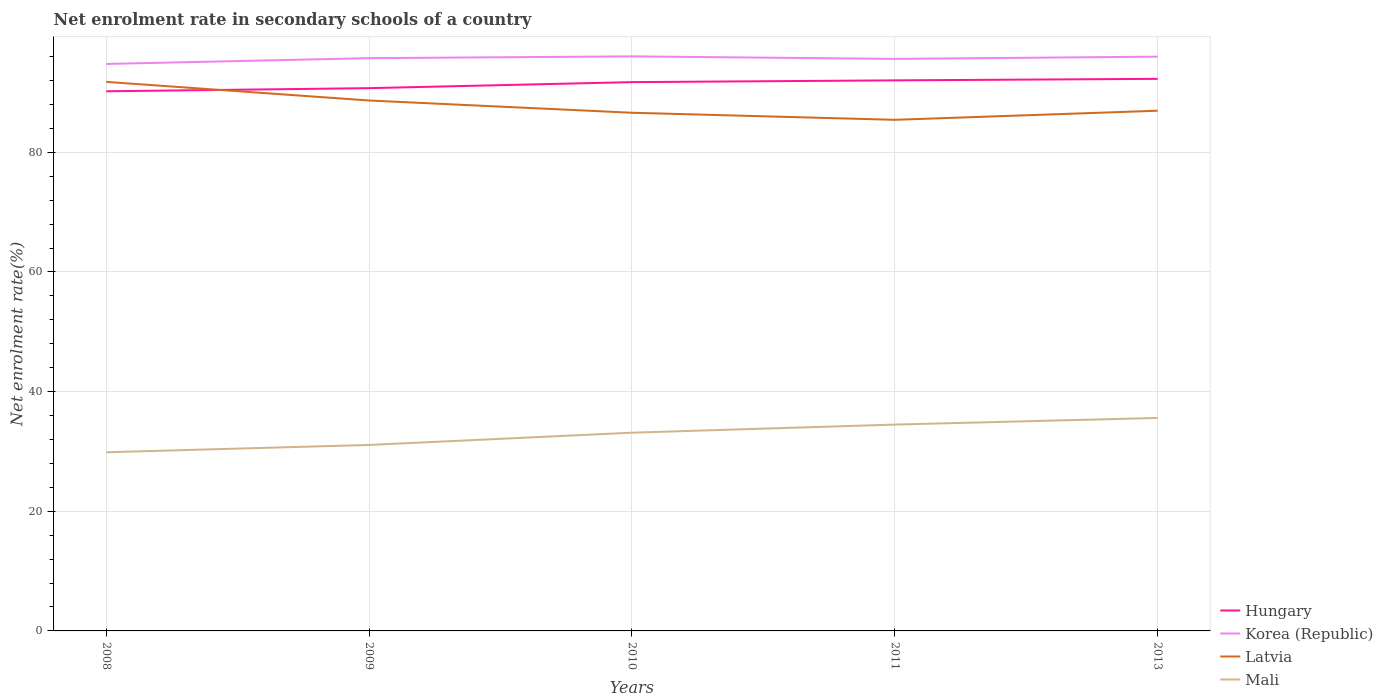How many different coloured lines are there?
Provide a succinct answer. 4. Does the line corresponding to Latvia intersect with the line corresponding to Korea (Republic)?
Your answer should be compact. No. Is the number of lines equal to the number of legend labels?
Provide a short and direct response. Yes. Across all years, what is the maximum net enrolment rate in secondary schools in Hungary?
Offer a terse response. 90.2. What is the total net enrolment rate in secondary schools in Korea (Republic) in the graph?
Provide a short and direct response. 0.42. What is the difference between the highest and the second highest net enrolment rate in secondary schools in Mali?
Make the answer very short. 5.74. Are the values on the major ticks of Y-axis written in scientific E-notation?
Ensure brevity in your answer.  No. Where does the legend appear in the graph?
Offer a very short reply. Bottom right. How are the legend labels stacked?
Offer a very short reply. Vertical. What is the title of the graph?
Keep it short and to the point. Net enrolment rate in secondary schools of a country. What is the label or title of the Y-axis?
Make the answer very short. Net enrolment rate(%). What is the Net enrolment rate(%) in Hungary in 2008?
Your response must be concise. 90.2. What is the Net enrolment rate(%) in Korea (Republic) in 2008?
Your answer should be very brief. 94.76. What is the Net enrolment rate(%) of Latvia in 2008?
Your answer should be compact. 91.77. What is the Net enrolment rate(%) of Mali in 2008?
Offer a terse response. 29.86. What is the Net enrolment rate(%) in Hungary in 2009?
Your response must be concise. 90.72. What is the Net enrolment rate(%) in Korea (Republic) in 2009?
Your answer should be compact. 95.73. What is the Net enrolment rate(%) in Latvia in 2009?
Give a very brief answer. 88.65. What is the Net enrolment rate(%) in Mali in 2009?
Provide a succinct answer. 31.09. What is the Net enrolment rate(%) in Hungary in 2010?
Provide a succinct answer. 91.72. What is the Net enrolment rate(%) of Korea (Republic) in 2010?
Ensure brevity in your answer.  96.03. What is the Net enrolment rate(%) of Latvia in 2010?
Provide a short and direct response. 86.61. What is the Net enrolment rate(%) in Mali in 2010?
Ensure brevity in your answer.  33.13. What is the Net enrolment rate(%) of Hungary in 2011?
Your answer should be very brief. 92.02. What is the Net enrolment rate(%) in Korea (Republic) in 2011?
Offer a very short reply. 95.61. What is the Net enrolment rate(%) of Latvia in 2011?
Keep it short and to the point. 85.43. What is the Net enrolment rate(%) in Mali in 2011?
Provide a short and direct response. 34.49. What is the Net enrolment rate(%) in Hungary in 2013?
Give a very brief answer. 92.27. What is the Net enrolment rate(%) of Korea (Republic) in 2013?
Keep it short and to the point. 95.98. What is the Net enrolment rate(%) of Latvia in 2013?
Keep it short and to the point. 86.94. What is the Net enrolment rate(%) in Mali in 2013?
Ensure brevity in your answer.  35.6. Across all years, what is the maximum Net enrolment rate(%) of Hungary?
Ensure brevity in your answer.  92.27. Across all years, what is the maximum Net enrolment rate(%) of Korea (Republic)?
Your response must be concise. 96.03. Across all years, what is the maximum Net enrolment rate(%) of Latvia?
Your response must be concise. 91.77. Across all years, what is the maximum Net enrolment rate(%) in Mali?
Your response must be concise. 35.6. Across all years, what is the minimum Net enrolment rate(%) in Hungary?
Keep it short and to the point. 90.2. Across all years, what is the minimum Net enrolment rate(%) of Korea (Republic)?
Your answer should be very brief. 94.76. Across all years, what is the minimum Net enrolment rate(%) of Latvia?
Provide a succinct answer. 85.43. Across all years, what is the minimum Net enrolment rate(%) of Mali?
Offer a terse response. 29.86. What is the total Net enrolment rate(%) of Hungary in the graph?
Provide a short and direct response. 456.93. What is the total Net enrolment rate(%) of Korea (Republic) in the graph?
Provide a succinct answer. 478.12. What is the total Net enrolment rate(%) in Latvia in the graph?
Provide a succinct answer. 439.4. What is the total Net enrolment rate(%) in Mali in the graph?
Offer a terse response. 164.16. What is the difference between the Net enrolment rate(%) of Hungary in 2008 and that in 2009?
Keep it short and to the point. -0.52. What is the difference between the Net enrolment rate(%) in Korea (Republic) in 2008 and that in 2009?
Make the answer very short. -0.97. What is the difference between the Net enrolment rate(%) of Latvia in 2008 and that in 2009?
Provide a succinct answer. 3.11. What is the difference between the Net enrolment rate(%) of Mali in 2008 and that in 2009?
Your answer should be compact. -1.23. What is the difference between the Net enrolment rate(%) in Hungary in 2008 and that in 2010?
Ensure brevity in your answer.  -1.53. What is the difference between the Net enrolment rate(%) in Korea (Republic) in 2008 and that in 2010?
Offer a very short reply. -1.27. What is the difference between the Net enrolment rate(%) of Latvia in 2008 and that in 2010?
Your response must be concise. 5.16. What is the difference between the Net enrolment rate(%) of Mali in 2008 and that in 2010?
Your response must be concise. -3.27. What is the difference between the Net enrolment rate(%) of Hungary in 2008 and that in 2011?
Offer a very short reply. -1.82. What is the difference between the Net enrolment rate(%) of Korea (Republic) in 2008 and that in 2011?
Give a very brief answer. -0.85. What is the difference between the Net enrolment rate(%) in Latvia in 2008 and that in 2011?
Give a very brief answer. 6.34. What is the difference between the Net enrolment rate(%) of Mali in 2008 and that in 2011?
Ensure brevity in your answer.  -4.63. What is the difference between the Net enrolment rate(%) in Hungary in 2008 and that in 2013?
Keep it short and to the point. -2.08. What is the difference between the Net enrolment rate(%) in Korea (Republic) in 2008 and that in 2013?
Keep it short and to the point. -1.22. What is the difference between the Net enrolment rate(%) in Latvia in 2008 and that in 2013?
Your response must be concise. 4.82. What is the difference between the Net enrolment rate(%) in Mali in 2008 and that in 2013?
Your answer should be very brief. -5.74. What is the difference between the Net enrolment rate(%) in Hungary in 2009 and that in 2010?
Your answer should be compact. -1.01. What is the difference between the Net enrolment rate(%) in Korea (Republic) in 2009 and that in 2010?
Provide a succinct answer. -0.3. What is the difference between the Net enrolment rate(%) in Latvia in 2009 and that in 2010?
Give a very brief answer. 2.05. What is the difference between the Net enrolment rate(%) of Mali in 2009 and that in 2010?
Provide a short and direct response. -2.05. What is the difference between the Net enrolment rate(%) of Hungary in 2009 and that in 2011?
Ensure brevity in your answer.  -1.3. What is the difference between the Net enrolment rate(%) in Korea (Republic) in 2009 and that in 2011?
Your answer should be compact. 0.12. What is the difference between the Net enrolment rate(%) of Latvia in 2009 and that in 2011?
Your answer should be very brief. 3.23. What is the difference between the Net enrolment rate(%) in Mali in 2009 and that in 2011?
Ensure brevity in your answer.  -3.4. What is the difference between the Net enrolment rate(%) in Hungary in 2009 and that in 2013?
Offer a very short reply. -1.56. What is the difference between the Net enrolment rate(%) of Latvia in 2009 and that in 2013?
Offer a very short reply. 1.71. What is the difference between the Net enrolment rate(%) in Mali in 2009 and that in 2013?
Keep it short and to the point. -4.51. What is the difference between the Net enrolment rate(%) of Hungary in 2010 and that in 2011?
Make the answer very short. -0.3. What is the difference between the Net enrolment rate(%) in Korea (Republic) in 2010 and that in 2011?
Ensure brevity in your answer.  0.42. What is the difference between the Net enrolment rate(%) of Latvia in 2010 and that in 2011?
Ensure brevity in your answer.  1.18. What is the difference between the Net enrolment rate(%) in Mali in 2010 and that in 2011?
Your response must be concise. -1.36. What is the difference between the Net enrolment rate(%) in Hungary in 2010 and that in 2013?
Offer a very short reply. -0.55. What is the difference between the Net enrolment rate(%) of Korea (Republic) in 2010 and that in 2013?
Keep it short and to the point. 0.05. What is the difference between the Net enrolment rate(%) in Latvia in 2010 and that in 2013?
Your response must be concise. -0.34. What is the difference between the Net enrolment rate(%) in Mali in 2010 and that in 2013?
Your answer should be compact. -2.47. What is the difference between the Net enrolment rate(%) in Hungary in 2011 and that in 2013?
Your answer should be compact. -0.25. What is the difference between the Net enrolment rate(%) of Korea (Republic) in 2011 and that in 2013?
Your response must be concise. -0.37. What is the difference between the Net enrolment rate(%) in Latvia in 2011 and that in 2013?
Your response must be concise. -1.52. What is the difference between the Net enrolment rate(%) in Mali in 2011 and that in 2013?
Provide a succinct answer. -1.11. What is the difference between the Net enrolment rate(%) of Hungary in 2008 and the Net enrolment rate(%) of Korea (Republic) in 2009?
Make the answer very short. -5.54. What is the difference between the Net enrolment rate(%) in Hungary in 2008 and the Net enrolment rate(%) in Latvia in 2009?
Your answer should be compact. 1.54. What is the difference between the Net enrolment rate(%) in Hungary in 2008 and the Net enrolment rate(%) in Mali in 2009?
Give a very brief answer. 59.11. What is the difference between the Net enrolment rate(%) in Korea (Republic) in 2008 and the Net enrolment rate(%) in Latvia in 2009?
Provide a short and direct response. 6.11. What is the difference between the Net enrolment rate(%) of Korea (Republic) in 2008 and the Net enrolment rate(%) of Mali in 2009?
Provide a short and direct response. 63.68. What is the difference between the Net enrolment rate(%) of Latvia in 2008 and the Net enrolment rate(%) of Mali in 2009?
Provide a succinct answer. 60.68. What is the difference between the Net enrolment rate(%) of Hungary in 2008 and the Net enrolment rate(%) of Korea (Republic) in 2010?
Offer a terse response. -5.83. What is the difference between the Net enrolment rate(%) in Hungary in 2008 and the Net enrolment rate(%) in Latvia in 2010?
Keep it short and to the point. 3.59. What is the difference between the Net enrolment rate(%) of Hungary in 2008 and the Net enrolment rate(%) of Mali in 2010?
Your response must be concise. 57.06. What is the difference between the Net enrolment rate(%) in Korea (Republic) in 2008 and the Net enrolment rate(%) in Latvia in 2010?
Your answer should be very brief. 8.16. What is the difference between the Net enrolment rate(%) in Korea (Republic) in 2008 and the Net enrolment rate(%) in Mali in 2010?
Your answer should be compact. 61.63. What is the difference between the Net enrolment rate(%) in Latvia in 2008 and the Net enrolment rate(%) in Mali in 2010?
Ensure brevity in your answer.  58.63. What is the difference between the Net enrolment rate(%) of Hungary in 2008 and the Net enrolment rate(%) of Korea (Republic) in 2011?
Give a very brief answer. -5.41. What is the difference between the Net enrolment rate(%) in Hungary in 2008 and the Net enrolment rate(%) in Latvia in 2011?
Your answer should be compact. 4.77. What is the difference between the Net enrolment rate(%) of Hungary in 2008 and the Net enrolment rate(%) of Mali in 2011?
Provide a succinct answer. 55.71. What is the difference between the Net enrolment rate(%) of Korea (Republic) in 2008 and the Net enrolment rate(%) of Latvia in 2011?
Your answer should be compact. 9.34. What is the difference between the Net enrolment rate(%) of Korea (Republic) in 2008 and the Net enrolment rate(%) of Mali in 2011?
Make the answer very short. 60.27. What is the difference between the Net enrolment rate(%) in Latvia in 2008 and the Net enrolment rate(%) in Mali in 2011?
Your answer should be compact. 57.28. What is the difference between the Net enrolment rate(%) of Hungary in 2008 and the Net enrolment rate(%) of Korea (Republic) in 2013?
Keep it short and to the point. -5.79. What is the difference between the Net enrolment rate(%) in Hungary in 2008 and the Net enrolment rate(%) in Latvia in 2013?
Keep it short and to the point. 3.25. What is the difference between the Net enrolment rate(%) in Hungary in 2008 and the Net enrolment rate(%) in Mali in 2013?
Your response must be concise. 54.6. What is the difference between the Net enrolment rate(%) in Korea (Republic) in 2008 and the Net enrolment rate(%) in Latvia in 2013?
Offer a terse response. 7.82. What is the difference between the Net enrolment rate(%) of Korea (Republic) in 2008 and the Net enrolment rate(%) of Mali in 2013?
Offer a very short reply. 59.16. What is the difference between the Net enrolment rate(%) of Latvia in 2008 and the Net enrolment rate(%) of Mali in 2013?
Keep it short and to the point. 56.17. What is the difference between the Net enrolment rate(%) of Hungary in 2009 and the Net enrolment rate(%) of Korea (Republic) in 2010?
Provide a succinct answer. -5.31. What is the difference between the Net enrolment rate(%) of Hungary in 2009 and the Net enrolment rate(%) of Latvia in 2010?
Provide a short and direct response. 4.11. What is the difference between the Net enrolment rate(%) of Hungary in 2009 and the Net enrolment rate(%) of Mali in 2010?
Keep it short and to the point. 57.59. What is the difference between the Net enrolment rate(%) in Korea (Republic) in 2009 and the Net enrolment rate(%) in Latvia in 2010?
Your answer should be very brief. 9.13. What is the difference between the Net enrolment rate(%) of Korea (Republic) in 2009 and the Net enrolment rate(%) of Mali in 2010?
Your response must be concise. 62.6. What is the difference between the Net enrolment rate(%) of Latvia in 2009 and the Net enrolment rate(%) of Mali in 2010?
Keep it short and to the point. 55.52. What is the difference between the Net enrolment rate(%) in Hungary in 2009 and the Net enrolment rate(%) in Korea (Republic) in 2011?
Provide a short and direct response. -4.89. What is the difference between the Net enrolment rate(%) of Hungary in 2009 and the Net enrolment rate(%) of Latvia in 2011?
Offer a very short reply. 5.29. What is the difference between the Net enrolment rate(%) in Hungary in 2009 and the Net enrolment rate(%) in Mali in 2011?
Give a very brief answer. 56.23. What is the difference between the Net enrolment rate(%) in Korea (Republic) in 2009 and the Net enrolment rate(%) in Latvia in 2011?
Offer a terse response. 10.31. What is the difference between the Net enrolment rate(%) of Korea (Republic) in 2009 and the Net enrolment rate(%) of Mali in 2011?
Your answer should be very brief. 61.24. What is the difference between the Net enrolment rate(%) in Latvia in 2009 and the Net enrolment rate(%) in Mali in 2011?
Your answer should be compact. 54.17. What is the difference between the Net enrolment rate(%) of Hungary in 2009 and the Net enrolment rate(%) of Korea (Republic) in 2013?
Provide a succinct answer. -5.26. What is the difference between the Net enrolment rate(%) of Hungary in 2009 and the Net enrolment rate(%) of Latvia in 2013?
Provide a succinct answer. 3.77. What is the difference between the Net enrolment rate(%) in Hungary in 2009 and the Net enrolment rate(%) in Mali in 2013?
Your answer should be very brief. 55.12. What is the difference between the Net enrolment rate(%) of Korea (Republic) in 2009 and the Net enrolment rate(%) of Latvia in 2013?
Keep it short and to the point. 8.79. What is the difference between the Net enrolment rate(%) of Korea (Republic) in 2009 and the Net enrolment rate(%) of Mali in 2013?
Offer a very short reply. 60.13. What is the difference between the Net enrolment rate(%) in Latvia in 2009 and the Net enrolment rate(%) in Mali in 2013?
Ensure brevity in your answer.  53.06. What is the difference between the Net enrolment rate(%) in Hungary in 2010 and the Net enrolment rate(%) in Korea (Republic) in 2011?
Give a very brief answer. -3.89. What is the difference between the Net enrolment rate(%) in Hungary in 2010 and the Net enrolment rate(%) in Latvia in 2011?
Ensure brevity in your answer.  6.3. What is the difference between the Net enrolment rate(%) in Hungary in 2010 and the Net enrolment rate(%) in Mali in 2011?
Provide a short and direct response. 57.24. What is the difference between the Net enrolment rate(%) in Korea (Republic) in 2010 and the Net enrolment rate(%) in Latvia in 2011?
Provide a short and direct response. 10.6. What is the difference between the Net enrolment rate(%) of Korea (Republic) in 2010 and the Net enrolment rate(%) of Mali in 2011?
Offer a terse response. 61.54. What is the difference between the Net enrolment rate(%) of Latvia in 2010 and the Net enrolment rate(%) of Mali in 2011?
Keep it short and to the point. 52.12. What is the difference between the Net enrolment rate(%) in Hungary in 2010 and the Net enrolment rate(%) in Korea (Republic) in 2013?
Give a very brief answer. -4.26. What is the difference between the Net enrolment rate(%) of Hungary in 2010 and the Net enrolment rate(%) of Latvia in 2013?
Provide a short and direct response. 4.78. What is the difference between the Net enrolment rate(%) of Hungary in 2010 and the Net enrolment rate(%) of Mali in 2013?
Make the answer very short. 56.13. What is the difference between the Net enrolment rate(%) of Korea (Republic) in 2010 and the Net enrolment rate(%) of Latvia in 2013?
Your answer should be compact. 9.08. What is the difference between the Net enrolment rate(%) in Korea (Republic) in 2010 and the Net enrolment rate(%) in Mali in 2013?
Give a very brief answer. 60.43. What is the difference between the Net enrolment rate(%) in Latvia in 2010 and the Net enrolment rate(%) in Mali in 2013?
Provide a short and direct response. 51.01. What is the difference between the Net enrolment rate(%) in Hungary in 2011 and the Net enrolment rate(%) in Korea (Republic) in 2013?
Provide a short and direct response. -3.96. What is the difference between the Net enrolment rate(%) of Hungary in 2011 and the Net enrolment rate(%) of Latvia in 2013?
Make the answer very short. 5.08. What is the difference between the Net enrolment rate(%) in Hungary in 2011 and the Net enrolment rate(%) in Mali in 2013?
Keep it short and to the point. 56.42. What is the difference between the Net enrolment rate(%) of Korea (Republic) in 2011 and the Net enrolment rate(%) of Latvia in 2013?
Keep it short and to the point. 8.66. What is the difference between the Net enrolment rate(%) in Korea (Republic) in 2011 and the Net enrolment rate(%) in Mali in 2013?
Offer a very short reply. 60.01. What is the difference between the Net enrolment rate(%) in Latvia in 2011 and the Net enrolment rate(%) in Mali in 2013?
Keep it short and to the point. 49.83. What is the average Net enrolment rate(%) in Hungary per year?
Offer a very short reply. 91.39. What is the average Net enrolment rate(%) in Korea (Republic) per year?
Offer a very short reply. 95.62. What is the average Net enrolment rate(%) of Latvia per year?
Make the answer very short. 87.88. What is the average Net enrolment rate(%) in Mali per year?
Provide a short and direct response. 32.83. In the year 2008, what is the difference between the Net enrolment rate(%) in Hungary and Net enrolment rate(%) in Korea (Republic)?
Ensure brevity in your answer.  -4.57. In the year 2008, what is the difference between the Net enrolment rate(%) of Hungary and Net enrolment rate(%) of Latvia?
Offer a very short reply. -1.57. In the year 2008, what is the difference between the Net enrolment rate(%) in Hungary and Net enrolment rate(%) in Mali?
Your answer should be compact. 60.34. In the year 2008, what is the difference between the Net enrolment rate(%) of Korea (Republic) and Net enrolment rate(%) of Latvia?
Provide a short and direct response. 3. In the year 2008, what is the difference between the Net enrolment rate(%) in Korea (Republic) and Net enrolment rate(%) in Mali?
Offer a terse response. 64.9. In the year 2008, what is the difference between the Net enrolment rate(%) in Latvia and Net enrolment rate(%) in Mali?
Make the answer very short. 61.91. In the year 2009, what is the difference between the Net enrolment rate(%) in Hungary and Net enrolment rate(%) in Korea (Republic)?
Your answer should be very brief. -5.01. In the year 2009, what is the difference between the Net enrolment rate(%) in Hungary and Net enrolment rate(%) in Latvia?
Provide a succinct answer. 2.06. In the year 2009, what is the difference between the Net enrolment rate(%) of Hungary and Net enrolment rate(%) of Mali?
Offer a very short reply. 59.63. In the year 2009, what is the difference between the Net enrolment rate(%) in Korea (Republic) and Net enrolment rate(%) in Latvia?
Keep it short and to the point. 7.08. In the year 2009, what is the difference between the Net enrolment rate(%) in Korea (Republic) and Net enrolment rate(%) in Mali?
Give a very brief answer. 64.65. In the year 2009, what is the difference between the Net enrolment rate(%) in Latvia and Net enrolment rate(%) in Mali?
Offer a terse response. 57.57. In the year 2010, what is the difference between the Net enrolment rate(%) of Hungary and Net enrolment rate(%) of Korea (Republic)?
Keep it short and to the point. -4.31. In the year 2010, what is the difference between the Net enrolment rate(%) in Hungary and Net enrolment rate(%) in Latvia?
Provide a short and direct response. 5.12. In the year 2010, what is the difference between the Net enrolment rate(%) in Hungary and Net enrolment rate(%) in Mali?
Provide a short and direct response. 58.59. In the year 2010, what is the difference between the Net enrolment rate(%) of Korea (Republic) and Net enrolment rate(%) of Latvia?
Provide a succinct answer. 9.42. In the year 2010, what is the difference between the Net enrolment rate(%) of Korea (Republic) and Net enrolment rate(%) of Mali?
Offer a terse response. 62.9. In the year 2010, what is the difference between the Net enrolment rate(%) of Latvia and Net enrolment rate(%) of Mali?
Your answer should be very brief. 53.47. In the year 2011, what is the difference between the Net enrolment rate(%) of Hungary and Net enrolment rate(%) of Korea (Republic)?
Give a very brief answer. -3.59. In the year 2011, what is the difference between the Net enrolment rate(%) of Hungary and Net enrolment rate(%) of Latvia?
Ensure brevity in your answer.  6.59. In the year 2011, what is the difference between the Net enrolment rate(%) in Hungary and Net enrolment rate(%) in Mali?
Your answer should be very brief. 57.53. In the year 2011, what is the difference between the Net enrolment rate(%) of Korea (Republic) and Net enrolment rate(%) of Latvia?
Make the answer very short. 10.18. In the year 2011, what is the difference between the Net enrolment rate(%) of Korea (Republic) and Net enrolment rate(%) of Mali?
Offer a terse response. 61.12. In the year 2011, what is the difference between the Net enrolment rate(%) of Latvia and Net enrolment rate(%) of Mali?
Offer a very short reply. 50.94. In the year 2013, what is the difference between the Net enrolment rate(%) in Hungary and Net enrolment rate(%) in Korea (Republic)?
Your answer should be compact. -3.71. In the year 2013, what is the difference between the Net enrolment rate(%) in Hungary and Net enrolment rate(%) in Latvia?
Make the answer very short. 5.33. In the year 2013, what is the difference between the Net enrolment rate(%) of Hungary and Net enrolment rate(%) of Mali?
Make the answer very short. 56.68. In the year 2013, what is the difference between the Net enrolment rate(%) of Korea (Republic) and Net enrolment rate(%) of Latvia?
Provide a short and direct response. 9.04. In the year 2013, what is the difference between the Net enrolment rate(%) in Korea (Republic) and Net enrolment rate(%) in Mali?
Provide a short and direct response. 60.38. In the year 2013, what is the difference between the Net enrolment rate(%) in Latvia and Net enrolment rate(%) in Mali?
Provide a succinct answer. 51.35. What is the ratio of the Net enrolment rate(%) of Hungary in 2008 to that in 2009?
Your answer should be very brief. 0.99. What is the ratio of the Net enrolment rate(%) of Latvia in 2008 to that in 2009?
Provide a short and direct response. 1.04. What is the ratio of the Net enrolment rate(%) in Mali in 2008 to that in 2009?
Provide a short and direct response. 0.96. What is the ratio of the Net enrolment rate(%) of Hungary in 2008 to that in 2010?
Your answer should be compact. 0.98. What is the ratio of the Net enrolment rate(%) of Latvia in 2008 to that in 2010?
Offer a terse response. 1.06. What is the ratio of the Net enrolment rate(%) of Mali in 2008 to that in 2010?
Make the answer very short. 0.9. What is the ratio of the Net enrolment rate(%) of Hungary in 2008 to that in 2011?
Keep it short and to the point. 0.98. What is the ratio of the Net enrolment rate(%) in Latvia in 2008 to that in 2011?
Your answer should be compact. 1.07. What is the ratio of the Net enrolment rate(%) of Mali in 2008 to that in 2011?
Give a very brief answer. 0.87. What is the ratio of the Net enrolment rate(%) of Hungary in 2008 to that in 2013?
Provide a short and direct response. 0.98. What is the ratio of the Net enrolment rate(%) in Korea (Republic) in 2008 to that in 2013?
Provide a short and direct response. 0.99. What is the ratio of the Net enrolment rate(%) of Latvia in 2008 to that in 2013?
Provide a short and direct response. 1.06. What is the ratio of the Net enrolment rate(%) of Mali in 2008 to that in 2013?
Ensure brevity in your answer.  0.84. What is the ratio of the Net enrolment rate(%) of Korea (Republic) in 2009 to that in 2010?
Keep it short and to the point. 1. What is the ratio of the Net enrolment rate(%) in Latvia in 2009 to that in 2010?
Your response must be concise. 1.02. What is the ratio of the Net enrolment rate(%) in Mali in 2009 to that in 2010?
Make the answer very short. 0.94. What is the ratio of the Net enrolment rate(%) in Hungary in 2009 to that in 2011?
Offer a terse response. 0.99. What is the ratio of the Net enrolment rate(%) of Latvia in 2009 to that in 2011?
Your response must be concise. 1.04. What is the ratio of the Net enrolment rate(%) of Mali in 2009 to that in 2011?
Keep it short and to the point. 0.9. What is the ratio of the Net enrolment rate(%) in Hungary in 2009 to that in 2013?
Give a very brief answer. 0.98. What is the ratio of the Net enrolment rate(%) in Latvia in 2009 to that in 2013?
Make the answer very short. 1.02. What is the ratio of the Net enrolment rate(%) of Mali in 2009 to that in 2013?
Provide a short and direct response. 0.87. What is the ratio of the Net enrolment rate(%) in Korea (Republic) in 2010 to that in 2011?
Offer a very short reply. 1. What is the ratio of the Net enrolment rate(%) in Latvia in 2010 to that in 2011?
Your response must be concise. 1.01. What is the ratio of the Net enrolment rate(%) in Mali in 2010 to that in 2011?
Ensure brevity in your answer.  0.96. What is the ratio of the Net enrolment rate(%) of Hungary in 2010 to that in 2013?
Keep it short and to the point. 0.99. What is the ratio of the Net enrolment rate(%) in Latvia in 2010 to that in 2013?
Provide a short and direct response. 1. What is the ratio of the Net enrolment rate(%) of Mali in 2010 to that in 2013?
Make the answer very short. 0.93. What is the ratio of the Net enrolment rate(%) in Korea (Republic) in 2011 to that in 2013?
Ensure brevity in your answer.  1. What is the ratio of the Net enrolment rate(%) of Latvia in 2011 to that in 2013?
Offer a very short reply. 0.98. What is the ratio of the Net enrolment rate(%) in Mali in 2011 to that in 2013?
Keep it short and to the point. 0.97. What is the difference between the highest and the second highest Net enrolment rate(%) in Hungary?
Your answer should be very brief. 0.25. What is the difference between the highest and the second highest Net enrolment rate(%) in Korea (Republic)?
Your answer should be very brief. 0.05. What is the difference between the highest and the second highest Net enrolment rate(%) in Latvia?
Make the answer very short. 3.11. What is the difference between the highest and the second highest Net enrolment rate(%) of Mali?
Provide a short and direct response. 1.11. What is the difference between the highest and the lowest Net enrolment rate(%) of Hungary?
Provide a short and direct response. 2.08. What is the difference between the highest and the lowest Net enrolment rate(%) in Korea (Republic)?
Your response must be concise. 1.27. What is the difference between the highest and the lowest Net enrolment rate(%) of Latvia?
Keep it short and to the point. 6.34. What is the difference between the highest and the lowest Net enrolment rate(%) of Mali?
Make the answer very short. 5.74. 